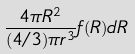<formula> <loc_0><loc_0><loc_500><loc_500>\frac { 4 \pi R ^ { 2 } } { ( 4 / 3 ) \pi r ^ { 3 } } f ( R ) d R</formula> 